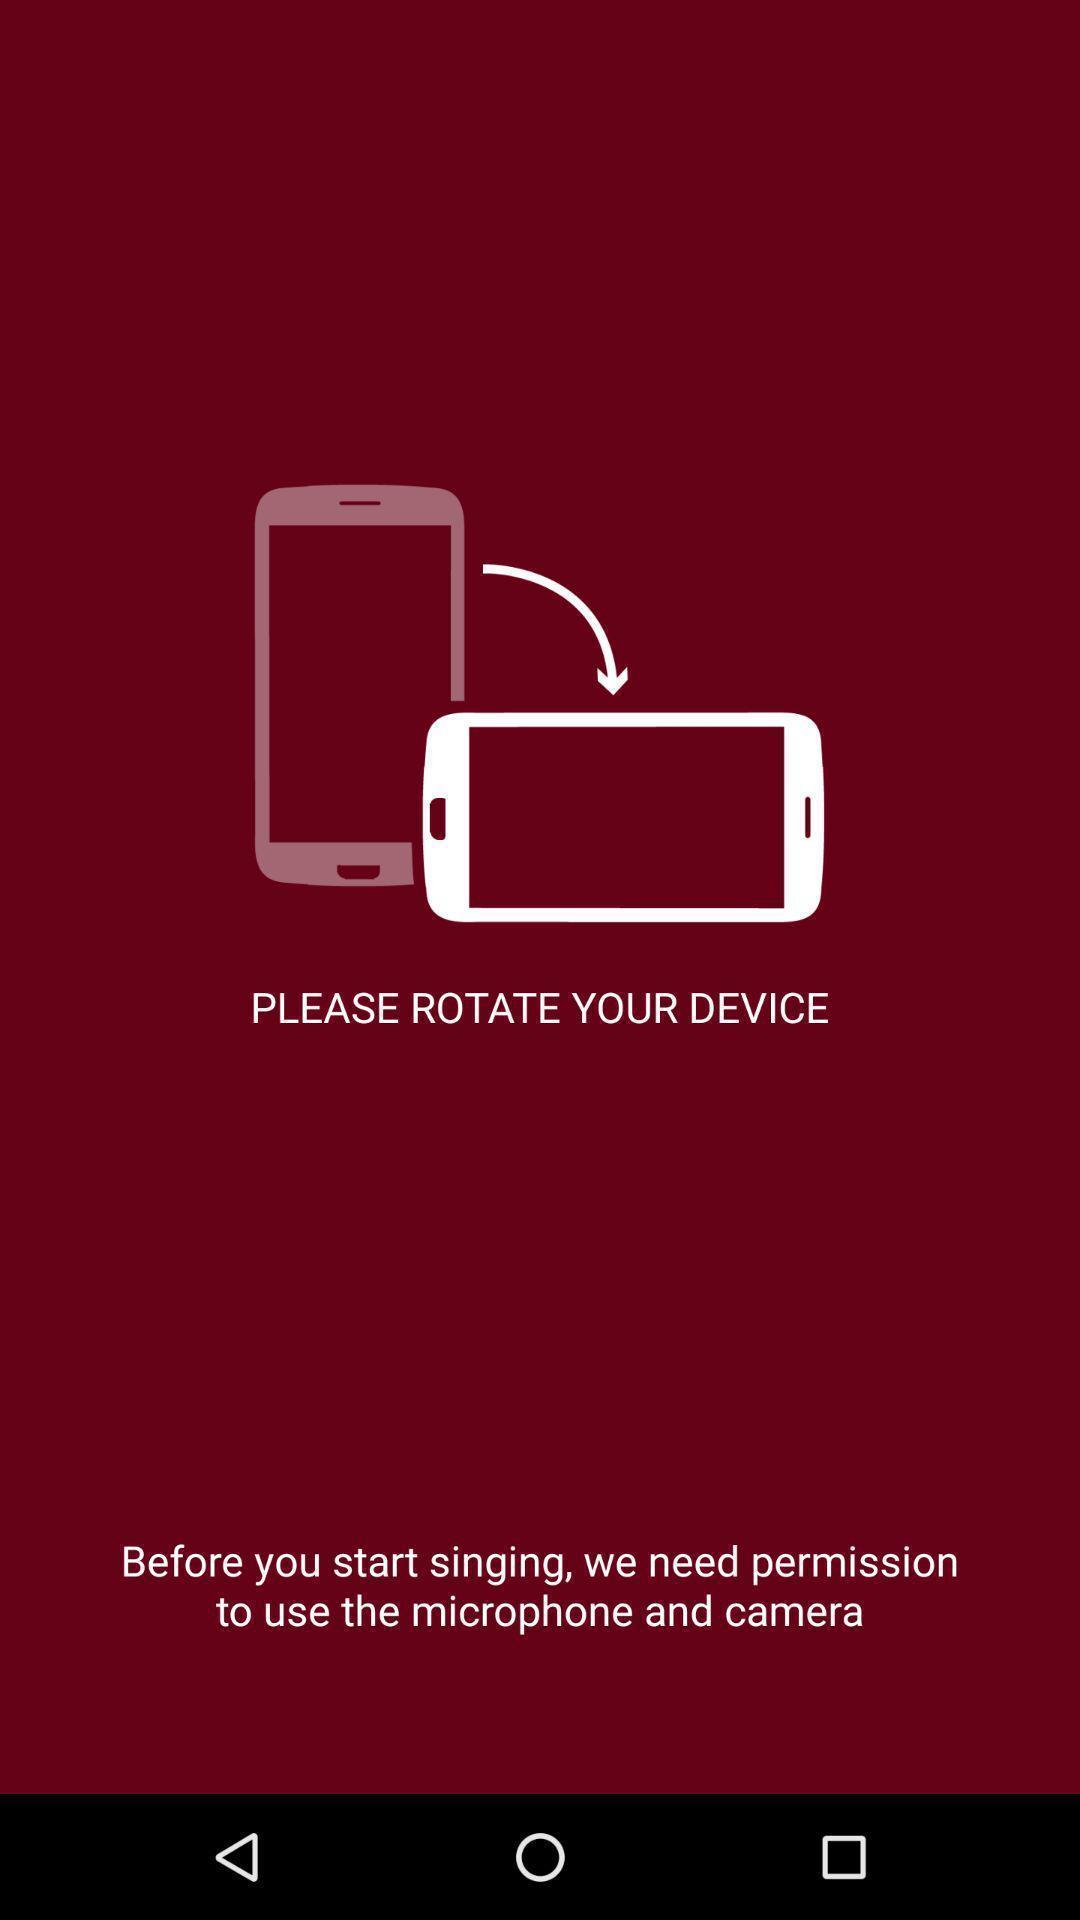Please provide a description for this image. Starting page. 